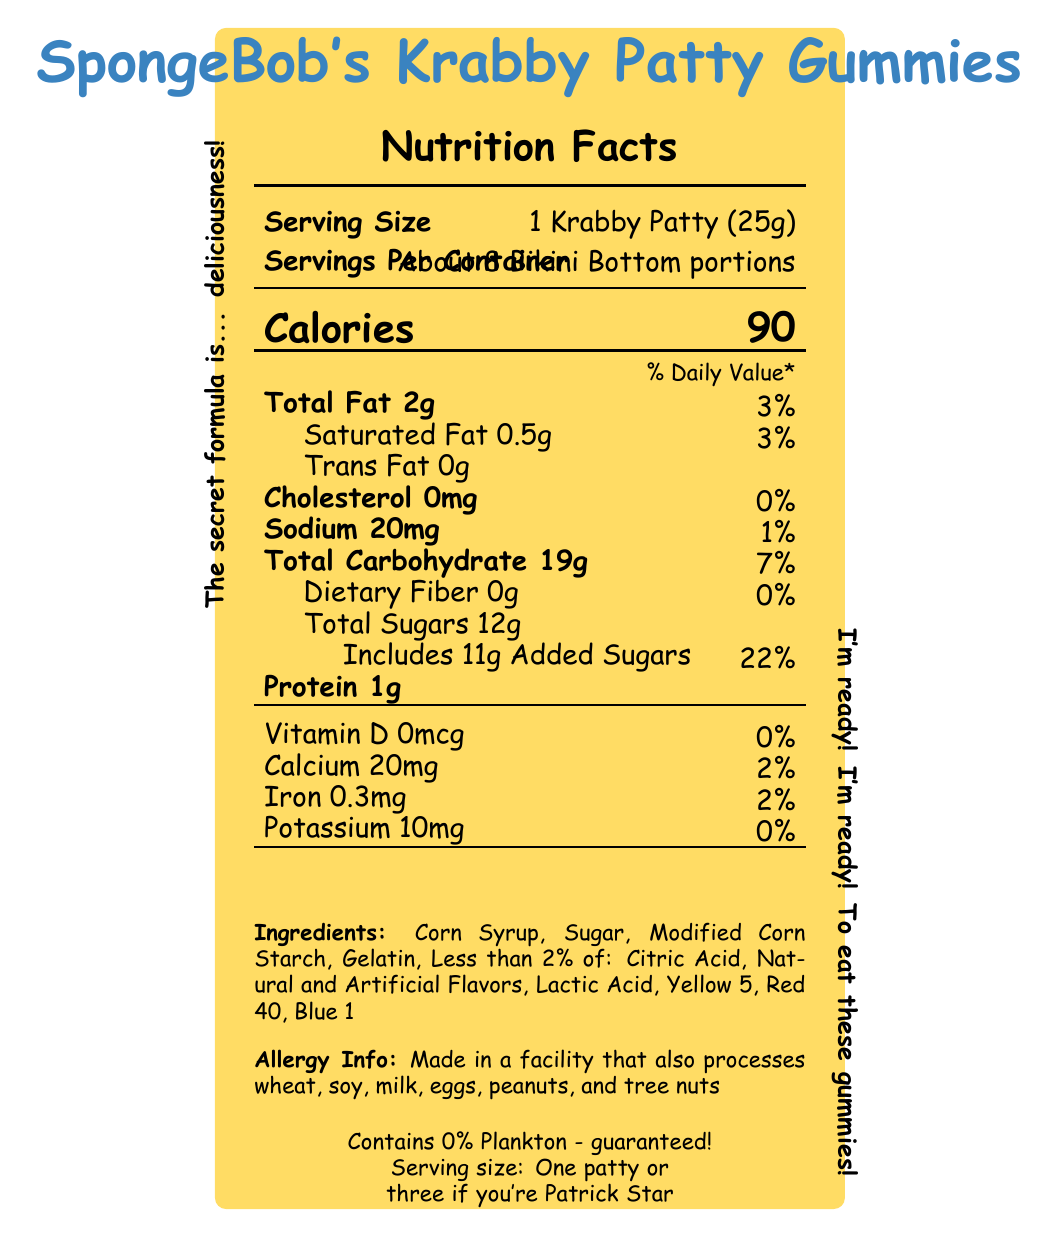What is the serving size of SpongeBob's Krabby Patty Gummies? The serving size is clearly stated as "1 Krabby Patty (25g)" in the document.
Answer: 1 Krabby Patty (25g) How many servings per container are indicated? The document mentions that there are "About 8 Bikini Bottom portions" per container.
Answer: About 8 Bikini Bottom portions How many calories are there in one serving? The document specifies that there are 90 calories per serving.
Answer: 90 What percentage of daily value is the total fat content? The total fat content is listed as 3% of the daily value in the document.
Answer: 3% How much sodium does one serving contain? The sodium content is clearly marked as 20mg in the document.
Answer: 20mg How many grams of total sugars are there per serving? The document states that there are 12g of total sugars per serving.
Answer: 12g Which vitamin is not present in SpongeBob's Krabby Patty Gummies? A. Vitamin A B. Vitamin C C. Vitamin D D. Vitamin E The document states "Vitamin D 0mcg (0%)", indicating that Vitamin D is not present.
Answer: C. Vitamin D What is the daily value percentage of added sugars in one serving? A. 11% B. 15% C. 22% D. 30% The document shows that added sugars amount to 11g, which is 22% of the daily value.
Answer: C. 22% Does the product contain any cholesterol? The cholesterol content is listed as 0mg (0%) in the document, indicating that there is no cholesterol in the product.
Answer: No Is this product safe for someone with a peanut allergy? The document's allergy info states that the product is made in a facility that also processes peanuts, which may not be safe for someone with a peanut allergy.
Answer: No What are the main ingredients in SpongeBob's Krabby Patty Gummies? The document lists these ingredients under the "Ingredients" section.
Answer: Corn Syrup, Sugar, Modified Corn Starch, Gelatin, Less than 2% of: Citric Acid, Natural and Artificial Flavors, Lactic Acid, Yellow 5, Red 40, Blue 1 What fun fact is given about the product? One of the fun facts stated in the document is that each gummy is shaped like the iconic Krabby Patty from the Krusty Krab.
Answer: Each gummy is shaped like the iconic Krabby Patty from the Krusty Krab! What humorous note is mentioned about the serving size for Patrick Star? The document includes a fun note saying "Serving size: One patty or three if you're Patrick Star."
Answer: Serving size: One patty or three if you're Patrick Star What does the phrase "Contains 0% Plankton - guaranteed!" signify in the document? This phrase is included as a humorous statement that references the cartoon's storyline.
Answer: It humorously guarantees that there is no plankton in the product Provide a brief summary of the SpongeBob's Krabby Patty Gummies nutrition facts label. A summary should capture all the essential information presented in the document.
Answer: The nutrition facts label describes a serving size of 1 Krabby Patty (25g) with about 8 servings per container. Each serving contains 90 calories, 2g of total fat (3% DV), 0.5g of saturated fat (3% DV), 0mg of cholesterol (0% DV), 20mg of sodium (1% DV), 19g of total carbohydrate (7% DV) including 0g of dietary fiber and 12g of total sugars (with 11g added sugars, 22% DV), and 1g of protein. It also provides vitamin and mineral content including 0% DV of vitamin D, 2% DV of calcium, 2% DV of iron, and 0% DV of potassium. The label emphasizes fun facts about the product's cartoon theme, details ingredients, and lists potential allergens. What is the primary source of protein in SpongeBob's Krabby Patty Gummies? The document lists the amount of protein but does not specify the source of protein in the gummies.
Answer: Not enough information 